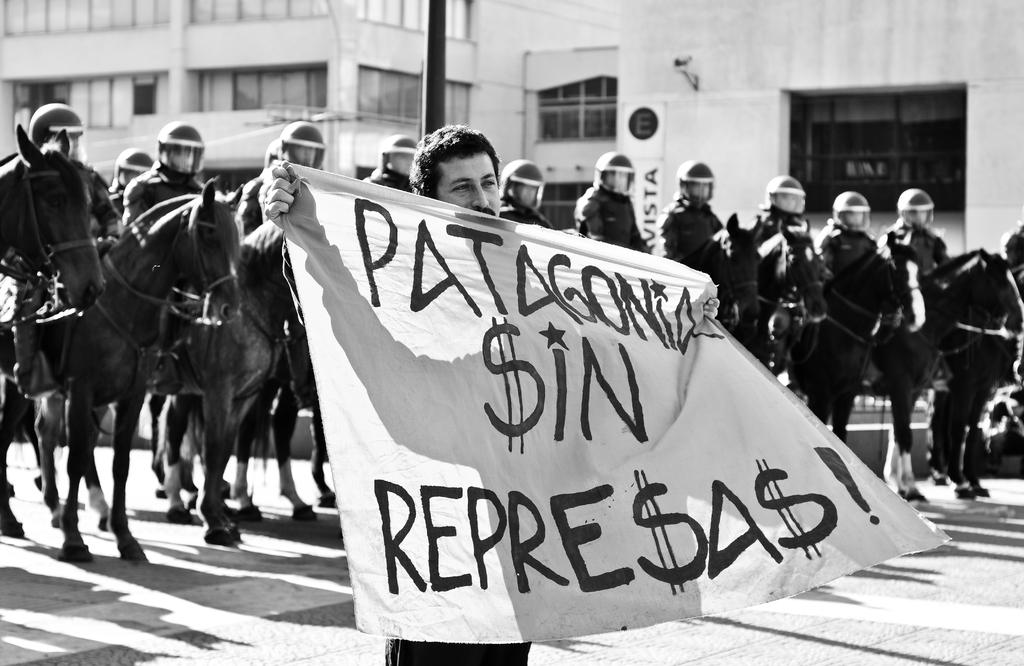What type of structures can be seen in the image? There are buildings in the image. What architectural feature is visible in the image? There is a window in the image. What are the people in the image doing? The people are sitting on horses in the image. What is the man in the front of the image doing? The man is standing in the front of the image and holding a banner. What type of drug can be seen in the image? There is no drug present in the image. Are there any trains visible in the image? There are no trains present in the image. 